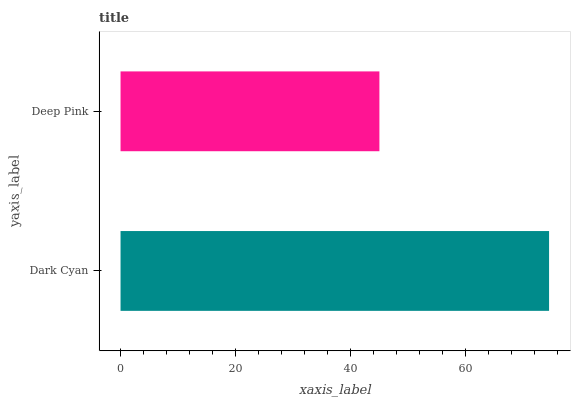Is Deep Pink the minimum?
Answer yes or no. Yes. Is Dark Cyan the maximum?
Answer yes or no. Yes. Is Deep Pink the maximum?
Answer yes or no. No. Is Dark Cyan greater than Deep Pink?
Answer yes or no. Yes. Is Deep Pink less than Dark Cyan?
Answer yes or no. Yes. Is Deep Pink greater than Dark Cyan?
Answer yes or no. No. Is Dark Cyan less than Deep Pink?
Answer yes or no. No. Is Dark Cyan the high median?
Answer yes or no. Yes. Is Deep Pink the low median?
Answer yes or no. Yes. Is Deep Pink the high median?
Answer yes or no. No. Is Dark Cyan the low median?
Answer yes or no. No. 